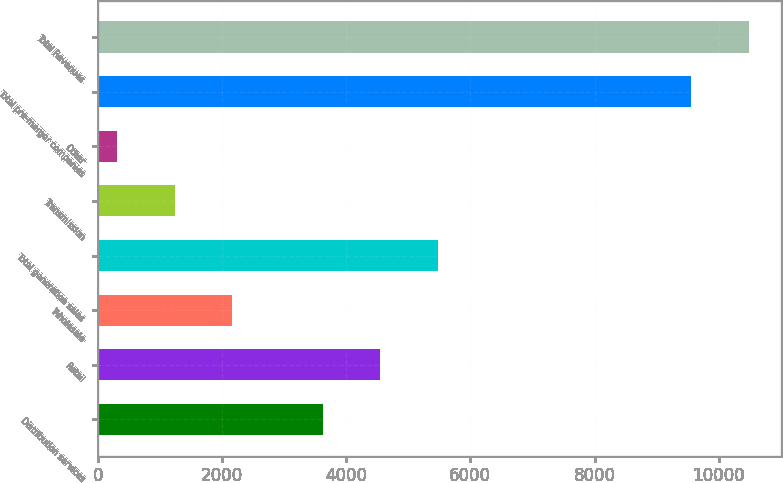Convert chart to OTSL. <chart><loc_0><loc_0><loc_500><loc_500><bar_chart><fcel>Distribution services<fcel>Retail<fcel>Wholesale<fcel>Total generation sales<fcel>Transmission<fcel>Other<fcel>Total pre-merger companies<fcel>Total Revenues<nl><fcel>3629<fcel>4553.2<fcel>2167.4<fcel>5477.4<fcel>1243.2<fcel>319<fcel>9561<fcel>10485.2<nl></chart> 